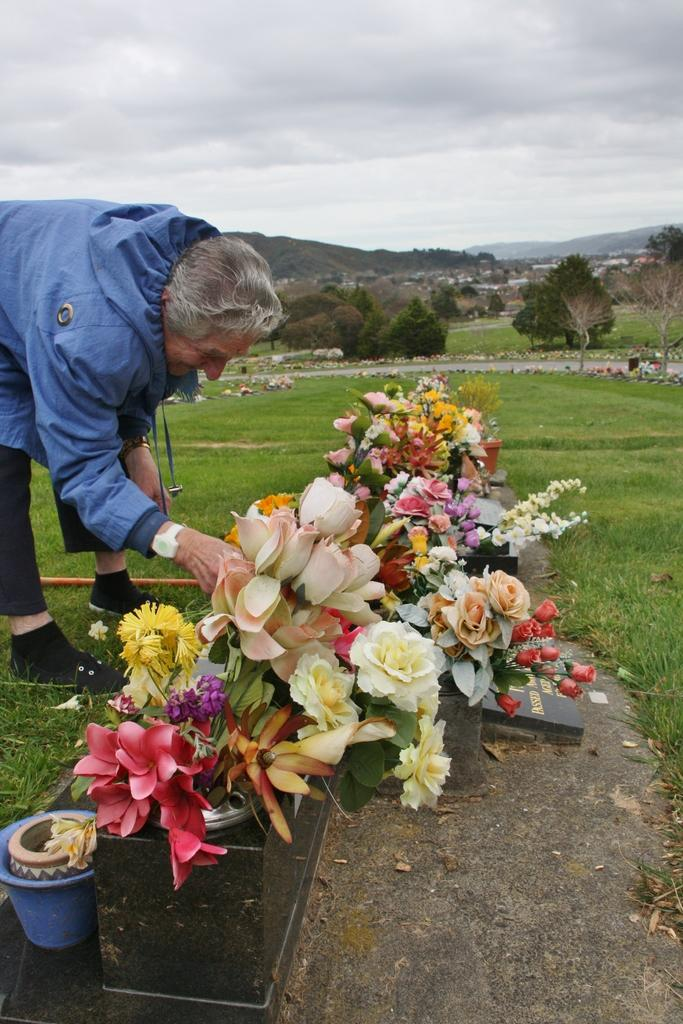What is the main subject in the center of the image? There are flowers in the center of the image. Can you describe the man on the left side of the image? There is a man on the left side of the image. What else can be seen in the center of the image besides the flowers? There is greenery in the center of the image. What is the tendency of the gold in the image? There is no gold present in the image, so it is not possible to determine its tendency. 